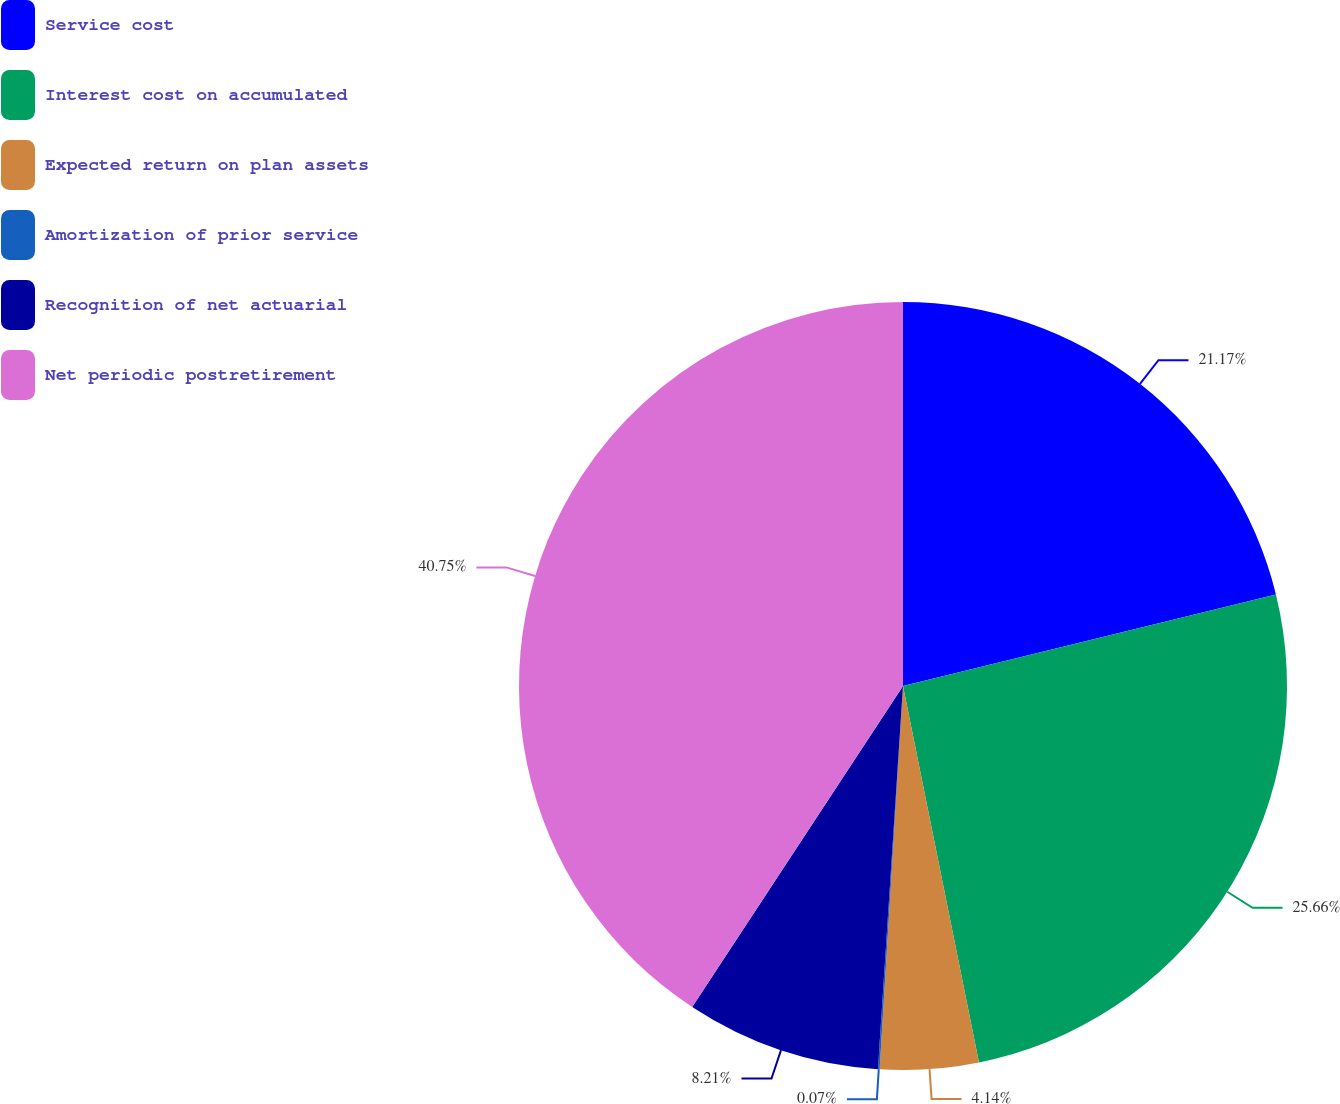Convert chart. <chart><loc_0><loc_0><loc_500><loc_500><pie_chart><fcel>Service cost<fcel>Interest cost on accumulated<fcel>Expected return on plan assets<fcel>Amortization of prior service<fcel>Recognition of net actuarial<fcel>Net periodic postretirement<nl><fcel>21.17%<fcel>25.66%<fcel>4.14%<fcel>0.07%<fcel>8.21%<fcel>40.75%<nl></chart> 